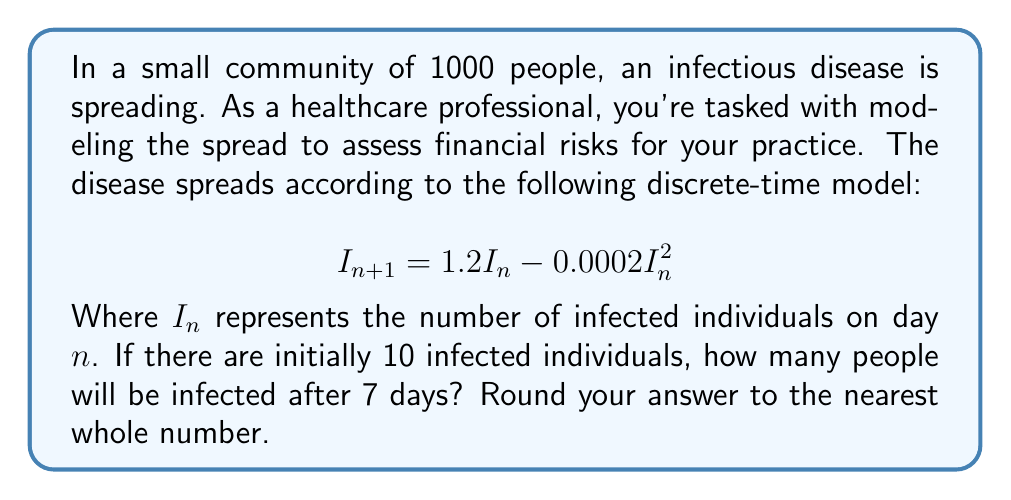What is the answer to this math problem? Let's approach this step-by-step:

1) We start with $I_0 = 10$ (initial infected population).

2) We'll use the recurrence relation to calculate the number of infected individuals for each subsequent day:

   For day 1: $I_1 = 1.2(10) - 0.0002(10)^2 = 12 - 0.02 = 11.98$

3) We continue this process for the next 6 days:

   Day 2: $I_2 = 1.2(11.98) - 0.0002(11.98)^2 = 14.33$
   Day 3: $I_3 = 1.2(14.33) - 0.0002(14.33)^2 = 17.10$
   Day 4: $I_4 = 1.2(17.10) - 0.0002(17.10)^2 = 20.37$
   Day 5: $I_5 = 1.2(20.37) - 0.0002(20.37)^2 = 24.18$
   Day 6: $I_6 = 1.2(24.18) - 0.0002(24.18)^2 = 28.55$
   Day 7: $I_7 = 1.2(28.55) - 0.0002(28.55)^2 = 33.49$

4) Rounding 33.49 to the nearest whole number gives us 33.

This model shows a rapid increase in infections over a week, which could have significant implications for healthcare resource allocation and financial planning in your practice.
Answer: 33 